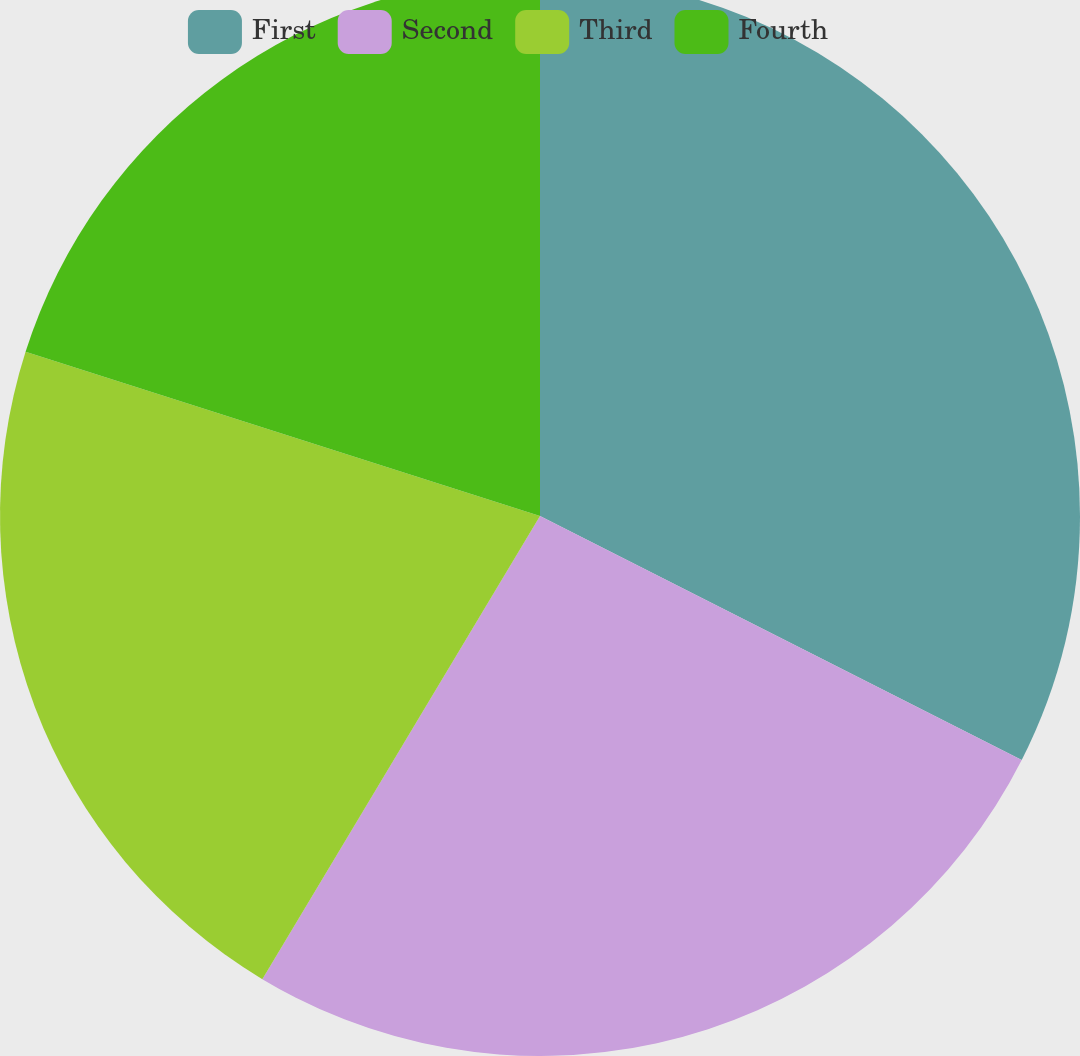<chart> <loc_0><loc_0><loc_500><loc_500><pie_chart><fcel>First<fcel>Second<fcel>Third<fcel>Fourth<nl><fcel>32.46%<fcel>26.13%<fcel>21.32%<fcel>20.08%<nl></chart> 